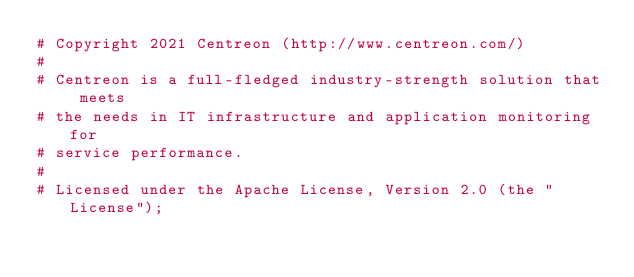<code> <loc_0><loc_0><loc_500><loc_500><_Perl_># Copyright 2021 Centreon (http://www.centreon.com/)
#
# Centreon is a full-fledged industry-strength solution that meets
# the needs in IT infrastructure and application monitoring for
# service performance.
#
# Licensed under the Apache License, Version 2.0 (the "License");</code> 